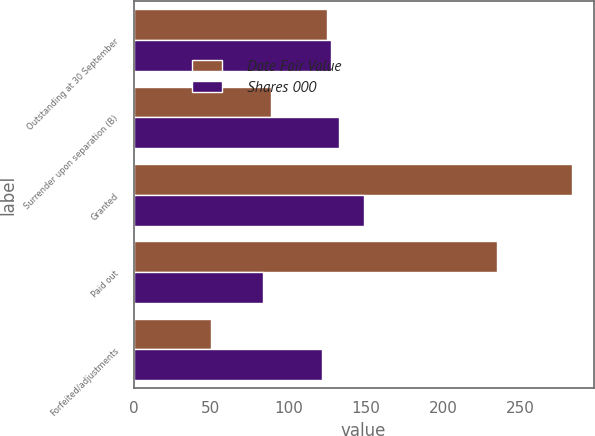Convert chart. <chart><loc_0><loc_0><loc_500><loc_500><stacked_bar_chart><ecel><fcel>Outstanding at 30 September<fcel>Surrender upon separation (B)<fcel>Granted<fcel>Paid out<fcel>Forfeited/adjustments<nl><fcel>Date Fair Value<fcel>124.64<fcel>89<fcel>283<fcel>235<fcel>50<nl><fcel>Shares 000<fcel>127.29<fcel>132.88<fcel>148.89<fcel>83.65<fcel>121.99<nl></chart> 